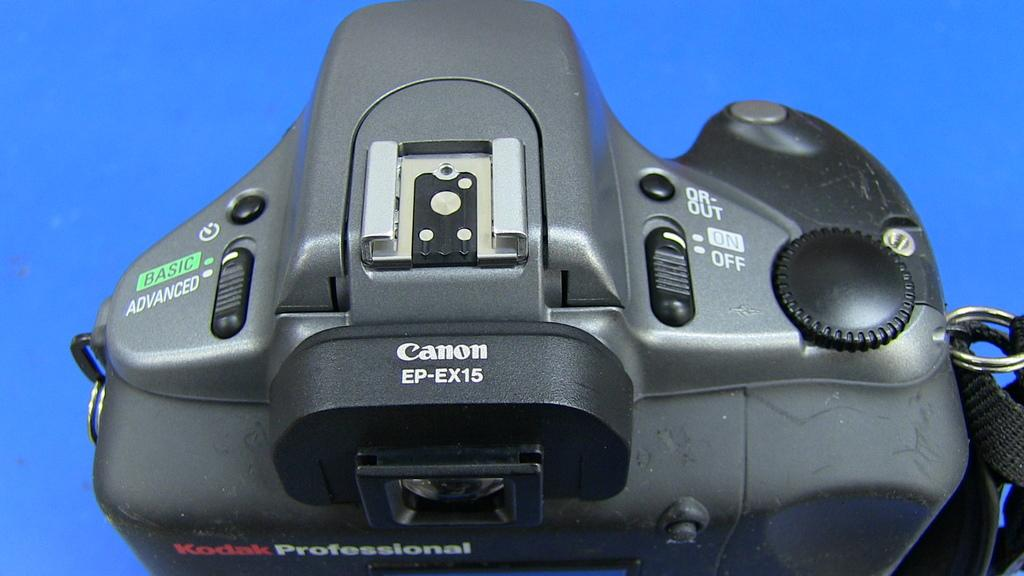<image>
Provide a brief description of the given image. The top side of a Canon camera has a few different buttons. 